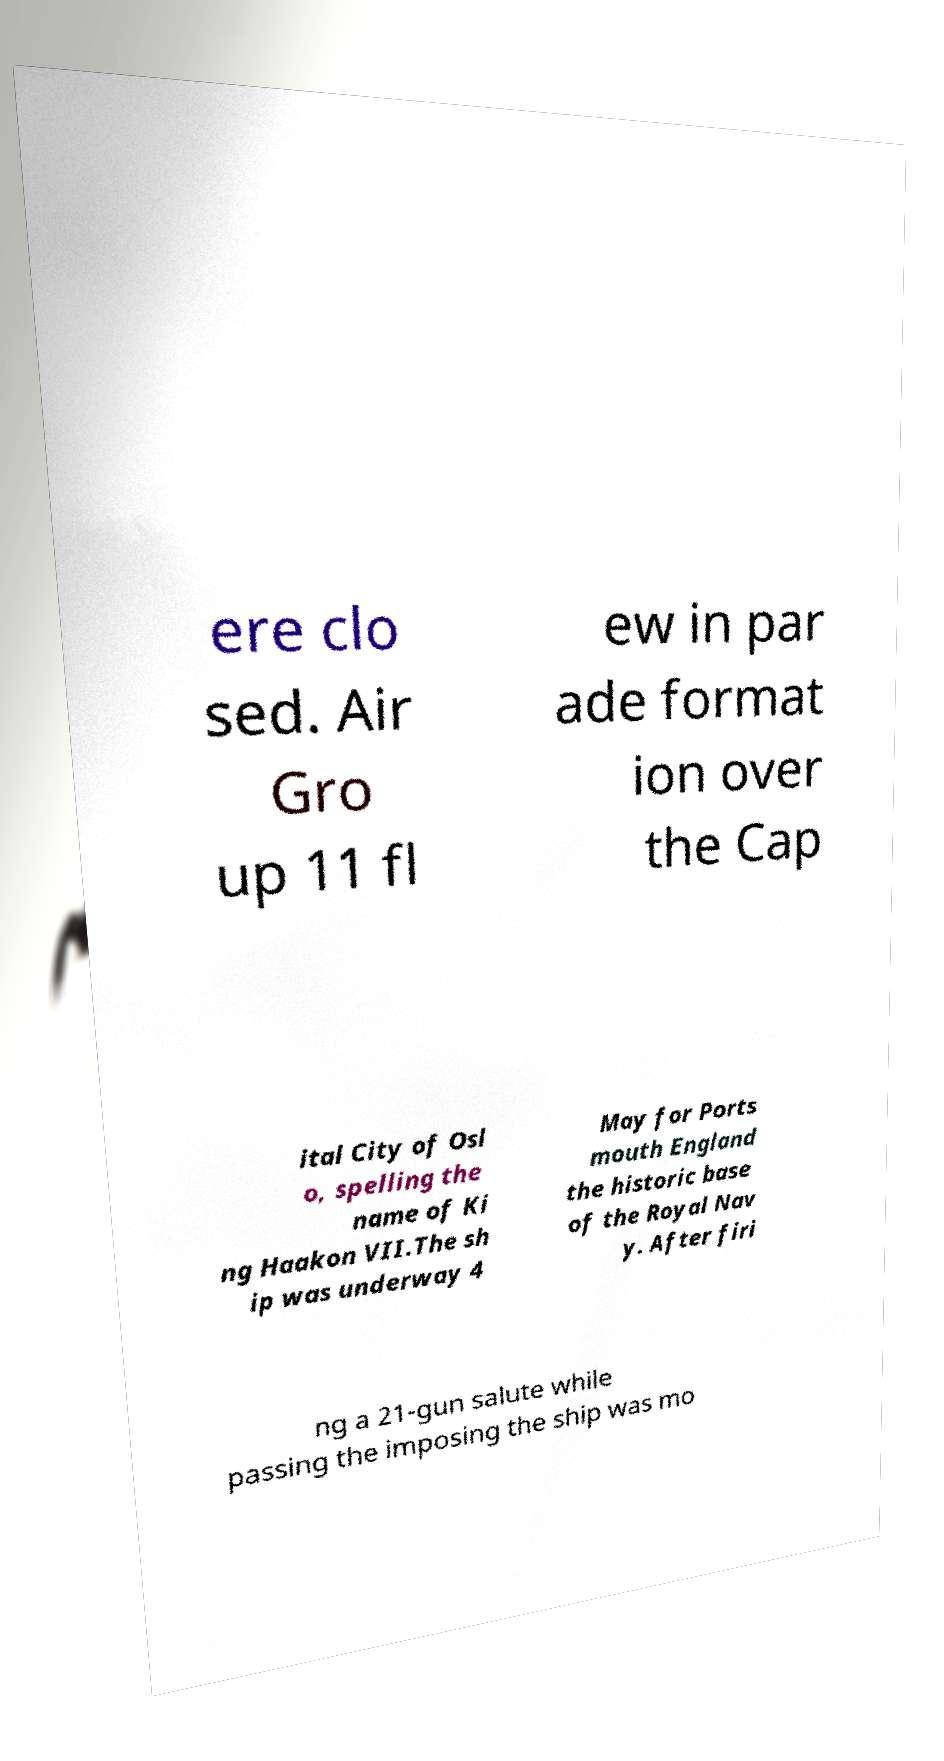Could you extract and type out the text from this image? ere clo sed. Air Gro up 11 fl ew in par ade format ion over the Cap ital City of Osl o, spelling the name of Ki ng Haakon VII.The sh ip was underway 4 May for Ports mouth England the historic base of the Royal Nav y. After firi ng a 21-gun salute while passing the imposing the ship was mo 